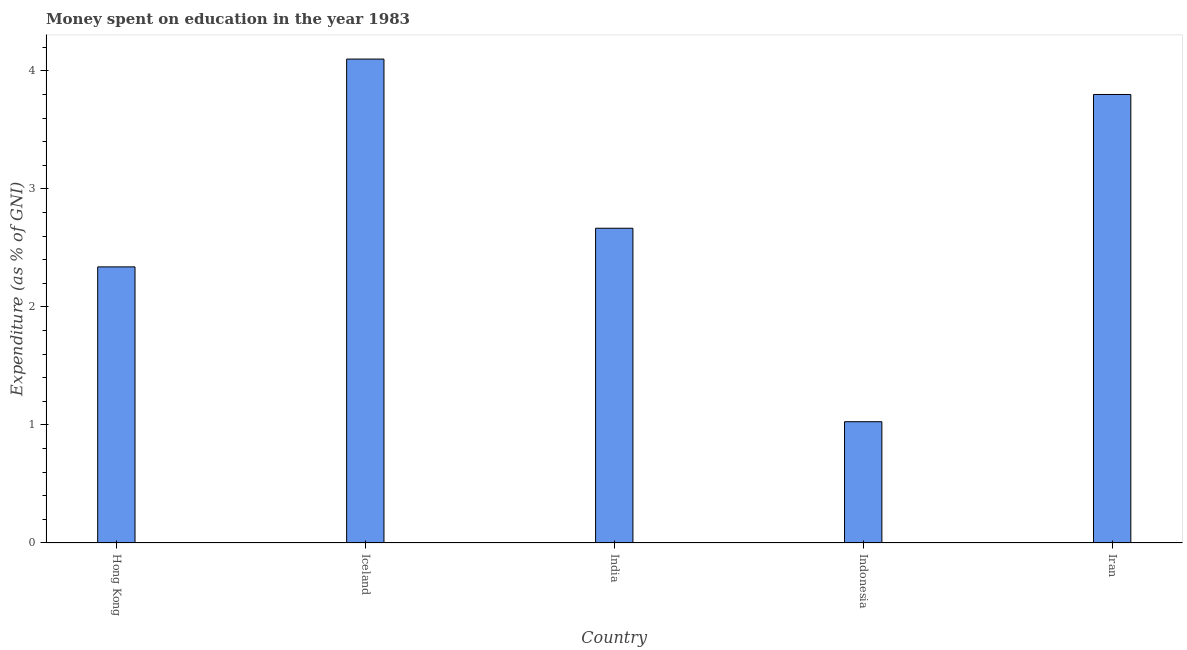Does the graph contain grids?
Provide a succinct answer. No. What is the title of the graph?
Your answer should be compact. Money spent on education in the year 1983. What is the label or title of the X-axis?
Ensure brevity in your answer.  Country. What is the label or title of the Y-axis?
Ensure brevity in your answer.  Expenditure (as % of GNI). What is the expenditure on education in India?
Ensure brevity in your answer.  2.67. Across all countries, what is the minimum expenditure on education?
Your answer should be very brief. 1.03. In which country was the expenditure on education maximum?
Your answer should be compact. Iceland. What is the sum of the expenditure on education?
Make the answer very short. 13.93. What is the difference between the expenditure on education in Indonesia and Iran?
Provide a short and direct response. -2.77. What is the average expenditure on education per country?
Offer a very short reply. 2.79. What is the median expenditure on education?
Your response must be concise. 2.67. In how many countries, is the expenditure on education greater than 3.4 %?
Your answer should be compact. 2. What is the ratio of the expenditure on education in Iceland to that in Indonesia?
Give a very brief answer. 3.99. Is the expenditure on education in Hong Kong less than that in Iceland?
Your response must be concise. Yes. Is the difference between the expenditure on education in Indonesia and Iran greater than the difference between any two countries?
Keep it short and to the point. No. Is the sum of the expenditure on education in India and Indonesia greater than the maximum expenditure on education across all countries?
Ensure brevity in your answer.  No. What is the difference between the highest and the lowest expenditure on education?
Your answer should be compact. 3.07. In how many countries, is the expenditure on education greater than the average expenditure on education taken over all countries?
Ensure brevity in your answer.  2. How many countries are there in the graph?
Your answer should be compact. 5. Are the values on the major ticks of Y-axis written in scientific E-notation?
Give a very brief answer. No. What is the Expenditure (as % of GNI) of Hong Kong?
Provide a short and direct response. 2.34. What is the Expenditure (as % of GNI) of Iceland?
Ensure brevity in your answer.  4.1. What is the Expenditure (as % of GNI) in India?
Provide a succinct answer. 2.67. What is the Expenditure (as % of GNI) of Indonesia?
Your answer should be very brief. 1.03. What is the Expenditure (as % of GNI) of Iran?
Your answer should be very brief. 3.8. What is the difference between the Expenditure (as % of GNI) in Hong Kong and Iceland?
Ensure brevity in your answer.  -1.76. What is the difference between the Expenditure (as % of GNI) in Hong Kong and India?
Ensure brevity in your answer.  -0.33. What is the difference between the Expenditure (as % of GNI) in Hong Kong and Indonesia?
Your answer should be very brief. 1.31. What is the difference between the Expenditure (as % of GNI) in Hong Kong and Iran?
Provide a succinct answer. -1.46. What is the difference between the Expenditure (as % of GNI) in Iceland and India?
Give a very brief answer. 1.43. What is the difference between the Expenditure (as % of GNI) in Iceland and Indonesia?
Provide a short and direct response. 3.07. What is the difference between the Expenditure (as % of GNI) in India and Indonesia?
Give a very brief answer. 1.64. What is the difference between the Expenditure (as % of GNI) in India and Iran?
Give a very brief answer. -1.13. What is the difference between the Expenditure (as % of GNI) in Indonesia and Iran?
Give a very brief answer. -2.77. What is the ratio of the Expenditure (as % of GNI) in Hong Kong to that in Iceland?
Offer a terse response. 0.57. What is the ratio of the Expenditure (as % of GNI) in Hong Kong to that in India?
Ensure brevity in your answer.  0.88. What is the ratio of the Expenditure (as % of GNI) in Hong Kong to that in Indonesia?
Give a very brief answer. 2.28. What is the ratio of the Expenditure (as % of GNI) in Hong Kong to that in Iran?
Give a very brief answer. 0.62. What is the ratio of the Expenditure (as % of GNI) in Iceland to that in India?
Your response must be concise. 1.54. What is the ratio of the Expenditure (as % of GNI) in Iceland to that in Indonesia?
Ensure brevity in your answer.  3.99. What is the ratio of the Expenditure (as % of GNI) in Iceland to that in Iran?
Offer a terse response. 1.08. What is the ratio of the Expenditure (as % of GNI) in India to that in Indonesia?
Offer a terse response. 2.6. What is the ratio of the Expenditure (as % of GNI) in India to that in Iran?
Your response must be concise. 0.7. What is the ratio of the Expenditure (as % of GNI) in Indonesia to that in Iran?
Offer a very short reply. 0.27. 